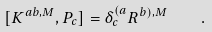<formula> <loc_0><loc_0><loc_500><loc_500>[ K ^ { a b , M } , P _ { c } ] = \delta ^ { ( a } _ { c } R ^ { b ) , M } \quad .</formula> 